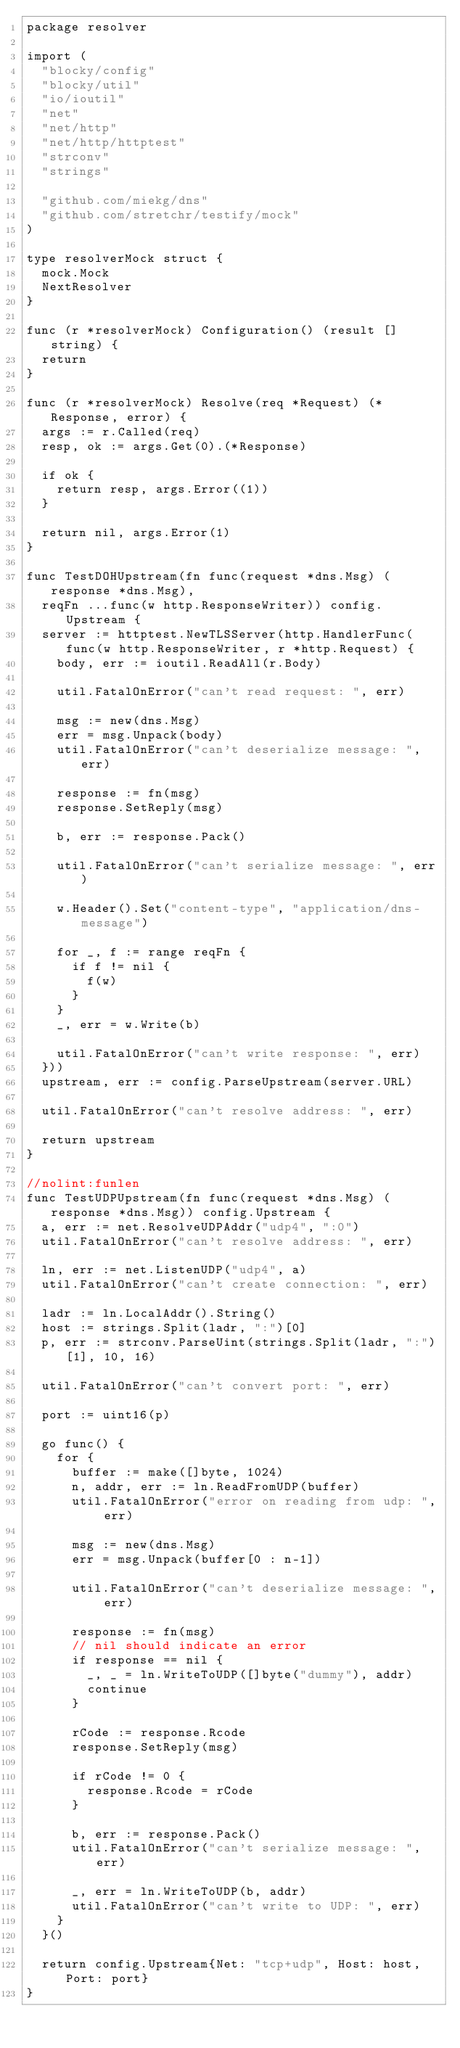<code> <loc_0><loc_0><loc_500><loc_500><_Go_>package resolver

import (
	"blocky/config"
	"blocky/util"
	"io/ioutil"
	"net"
	"net/http"
	"net/http/httptest"
	"strconv"
	"strings"

	"github.com/miekg/dns"
	"github.com/stretchr/testify/mock"
)

type resolverMock struct {
	mock.Mock
	NextResolver
}

func (r *resolverMock) Configuration() (result []string) {
	return
}

func (r *resolverMock) Resolve(req *Request) (*Response, error) {
	args := r.Called(req)
	resp, ok := args.Get(0).(*Response)

	if ok {
		return resp, args.Error((1))
	}

	return nil, args.Error(1)
}

func TestDOHUpstream(fn func(request *dns.Msg) (response *dns.Msg),
	reqFn ...func(w http.ResponseWriter)) config.Upstream {
	server := httptest.NewTLSServer(http.HandlerFunc(func(w http.ResponseWriter, r *http.Request) {
		body, err := ioutil.ReadAll(r.Body)

		util.FatalOnError("can't read request: ", err)

		msg := new(dns.Msg)
		err = msg.Unpack(body)
		util.FatalOnError("can't deserialize message: ", err)

		response := fn(msg)
		response.SetReply(msg)

		b, err := response.Pack()

		util.FatalOnError("can't serialize message: ", err)

		w.Header().Set("content-type", "application/dns-message")

		for _, f := range reqFn {
			if f != nil {
				f(w)
			}
		}
		_, err = w.Write(b)

		util.FatalOnError("can't write response: ", err)
	}))
	upstream, err := config.ParseUpstream(server.URL)

	util.FatalOnError("can't resolve address: ", err)

	return upstream
}

//nolint:funlen
func TestUDPUpstream(fn func(request *dns.Msg) (response *dns.Msg)) config.Upstream {
	a, err := net.ResolveUDPAddr("udp4", ":0")
	util.FatalOnError("can't resolve address: ", err)

	ln, err := net.ListenUDP("udp4", a)
	util.FatalOnError("can't create connection: ", err)

	ladr := ln.LocalAddr().String()
	host := strings.Split(ladr, ":")[0]
	p, err := strconv.ParseUint(strings.Split(ladr, ":")[1], 10, 16)

	util.FatalOnError("can't convert port: ", err)

	port := uint16(p)

	go func() {
		for {
			buffer := make([]byte, 1024)
			n, addr, err := ln.ReadFromUDP(buffer)
			util.FatalOnError("error on reading from udp: ", err)

			msg := new(dns.Msg)
			err = msg.Unpack(buffer[0 : n-1])

			util.FatalOnError("can't deserialize message: ", err)

			response := fn(msg)
			// nil should indicate an error
			if response == nil {
				_, _ = ln.WriteToUDP([]byte("dummy"), addr)
				continue
			}

			rCode := response.Rcode
			response.SetReply(msg)

			if rCode != 0 {
				response.Rcode = rCode
			}

			b, err := response.Pack()
			util.FatalOnError("can't serialize message: ", err)

			_, err = ln.WriteToUDP(b, addr)
			util.FatalOnError("can't write to UDP: ", err)
		}
	}()

	return config.Upstream{Net: "tcp+udp", Host: host, Port: port}
}
</code> 